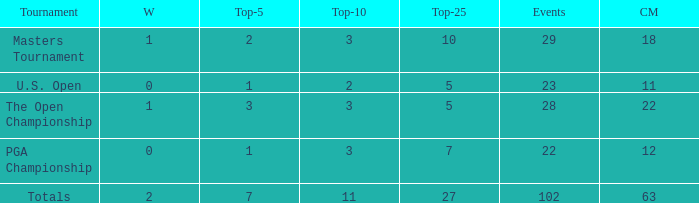How many top 10s when he had under 1 top 5s? None. 